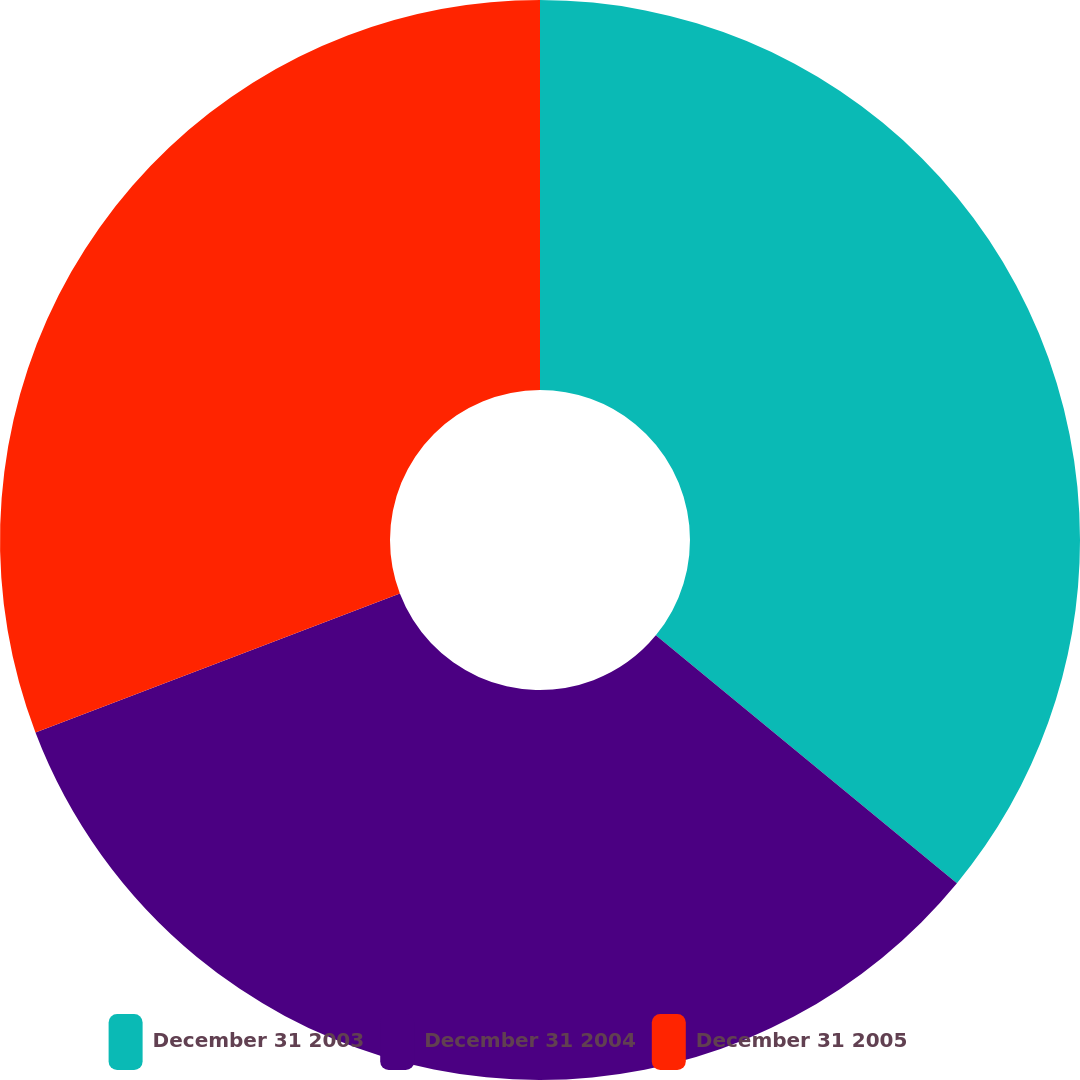Convert chart. <chart><loc_0><loc_0><loc_500><loc_500><pie_chart><fcel>December 31 2003<fcel>December 31 2004<fcel>December 31 2005<nl><fcel>35.96%<fcel>33.24%<fcel>30.8%<nl></chart> 